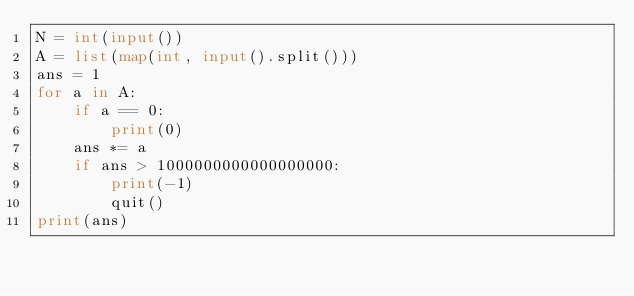<code> <loc_0><loc_0><loc_500><loc_500><_Python_>N = int(input())
A = list(map(int, input().split()))
ans = 1
for a in A:
    if a == 0:
        print(0)
    ans *= a
    if ans > 1000000000000000000:
        print(-1)
        quit()
print(ans)</code> 